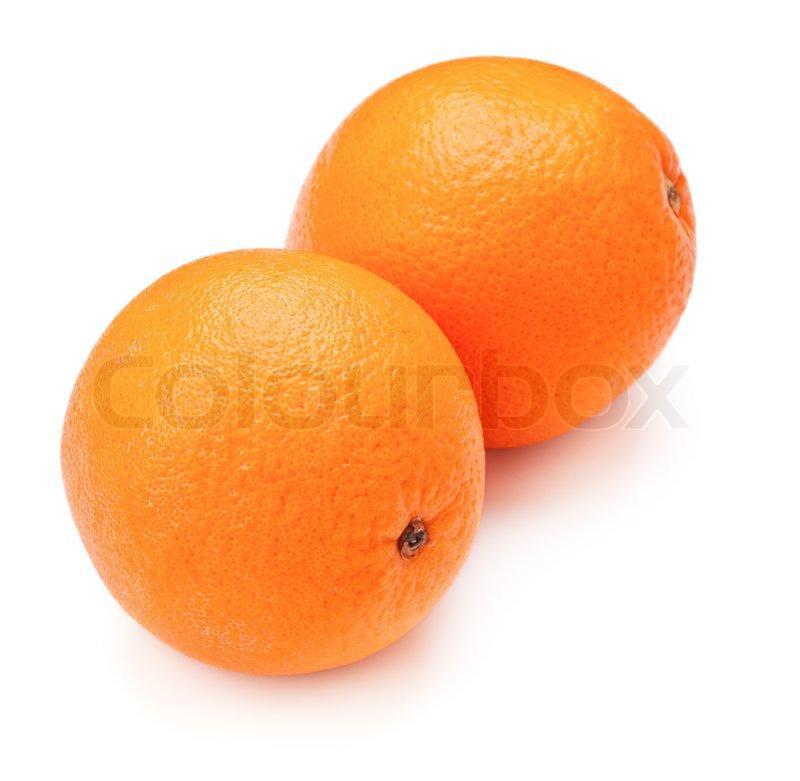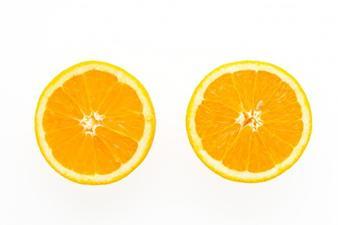The first image is the image on the left, the second image is the image on the right. Examine the images to the left and right. Is the description "There are three whole oranges and a half an orange in the image pair." accurate? Answer yes or no. No. The first image is the image on the left, the second image is the image on the right. Examine the images to the left and right. Is the description "The right image contains at least one orange that is sliced in half." accurate? Answer yes or no. Yes. 